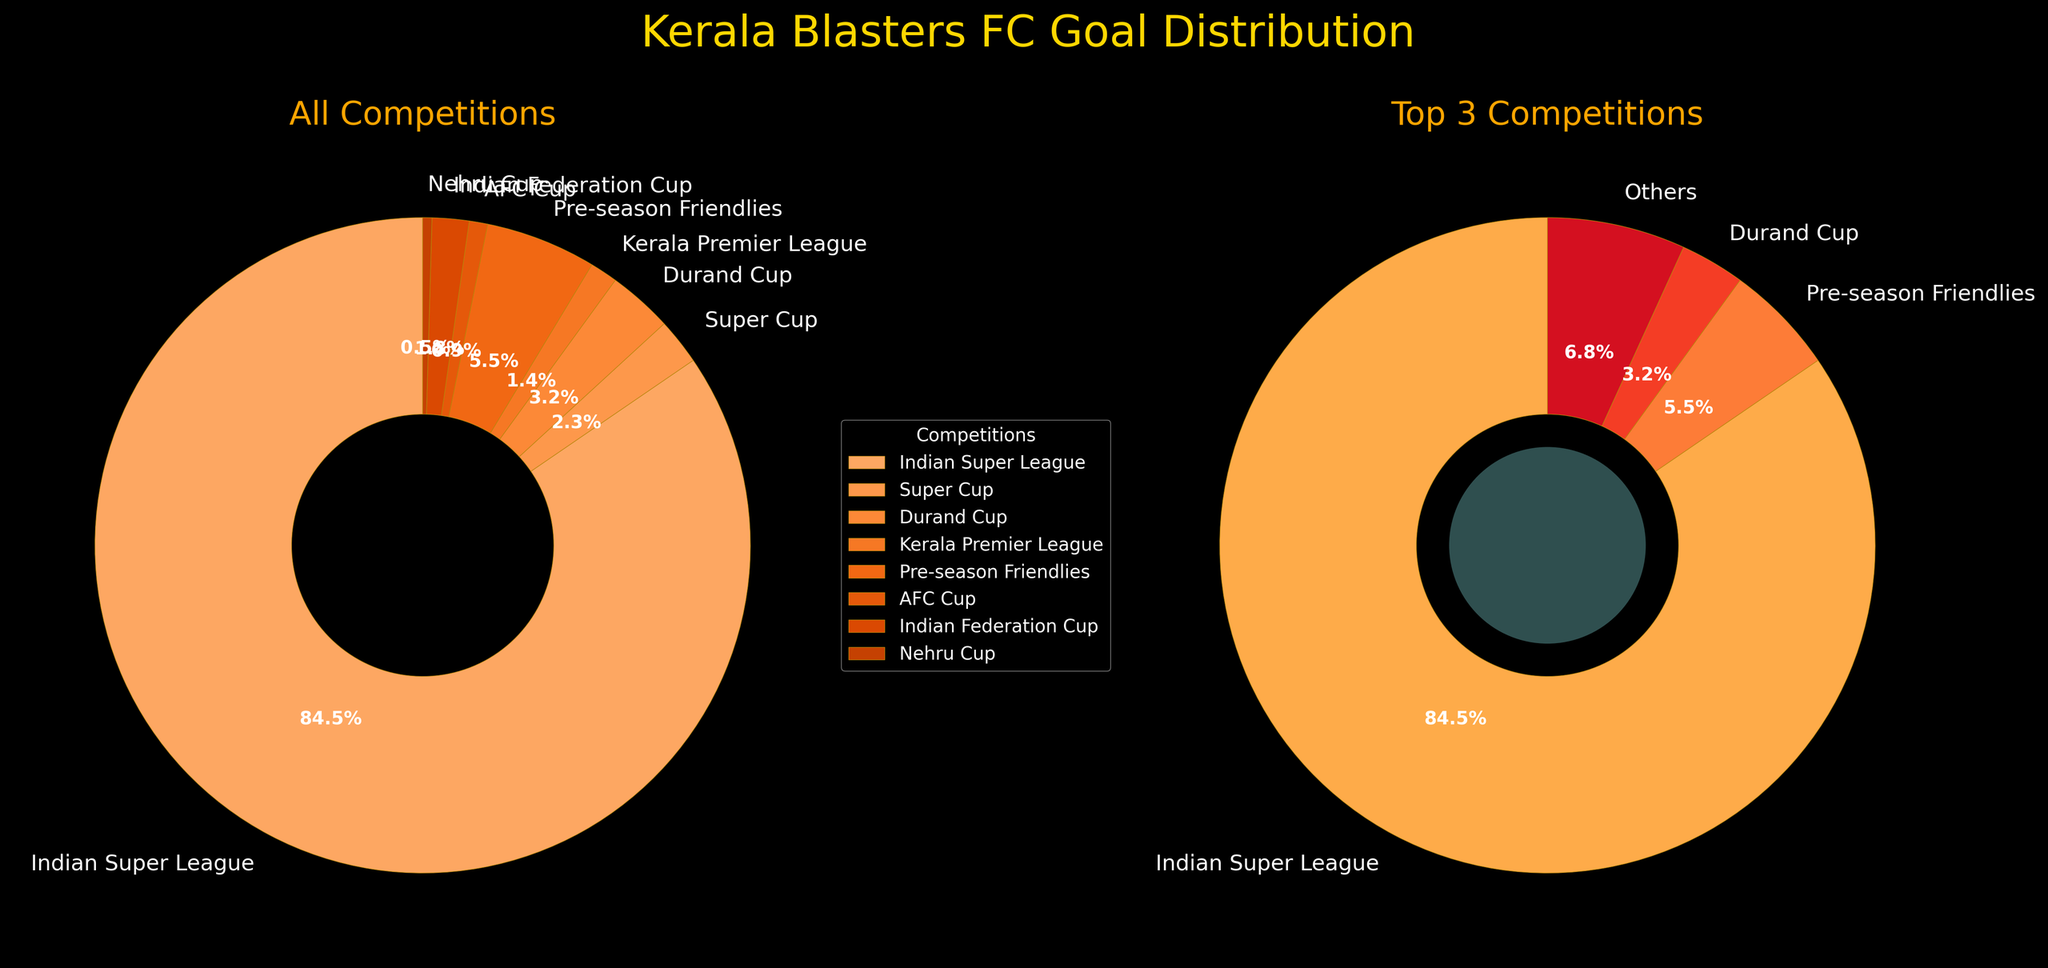How many goals has Kerala Blasters FC scored in the Indian Super League and Super Cup combined? Add the goals from the Indian Super League (186) and the Super Cup (5). 186 + 5 is 191.
Answer: 191 Which competition has the least number of goals scored by Kerala Blasters FC, and how many goals are there? The Nehru Cup has the fewest goals with just 1 goal.
Answer: Nehru Cup, 1 Compare the goal percentages in the Indian Super League and Pre-season Friendlies. Which one is higher and by how much? The Indian Super League has 186 goals and Pre-season Friendlies have 12 goals. Calculate their percentage: (186/220)*100 ≈ 84.5%, (12/220)*100 ≈ 5.5%. The difference is 84.5% - 5.5% = 79%.
Answer: Indian Super League, 79% What is the percentage of goals scored in competitions outside the Indian Super League? First, calculate the total number of goals scored (220). Subtract Indian Super League goals: 220 - 186 = 34. Then, calculate the percentage: (34/220)*100 ≈ 15.5%.
Answer: 15.5% In the donut chart for the top 3 competitions, how is the category 'Others' defined and what percentage of total goals does it represent? 'Others' groups the goals from competitions other than the top 3. To find the percentage: sum of 'Others' goals is 3 + 2 + 4 + 1 = 10, total goals = 220, calculate percentage: (10/220)*100 ≈ 4.5%.
Answer: 4.5% Which three competitions contribute to the 'Top 3 Competitions' section of the donut chart, and what are their respective percentages? The top three competitions by goals are Indian Super League, Pre-season Friendlies, and Durand Cup. Their goals are: 186, 12, and 7 respectively. Percentages: (186/220)*100 ≈ 84.5%, (12/220)*100 ≈ 5.5%, (7/220)*100 ≈ 3.2%.
Answer: Indian Super League: 84.5%, Pre-season Friendlies: 5.5%, Durand Cup: 3.2% What is the combined percentage of goals from the Kerala Premier League, AFC Cup, and Indian Federation Cup? Add the goals from these competitions: 3 + 2 + 4 = 9. Calculate the percentage: (9/220)*100 ≈ 4.1%.
Answer: 4.1% Of the goals not in the top 3 competitions, which individual competition contributes the most? The individual competition with the most goals outside the top 3 is the Super Cup with 5 goals.
Answer: Super Cup, 5 